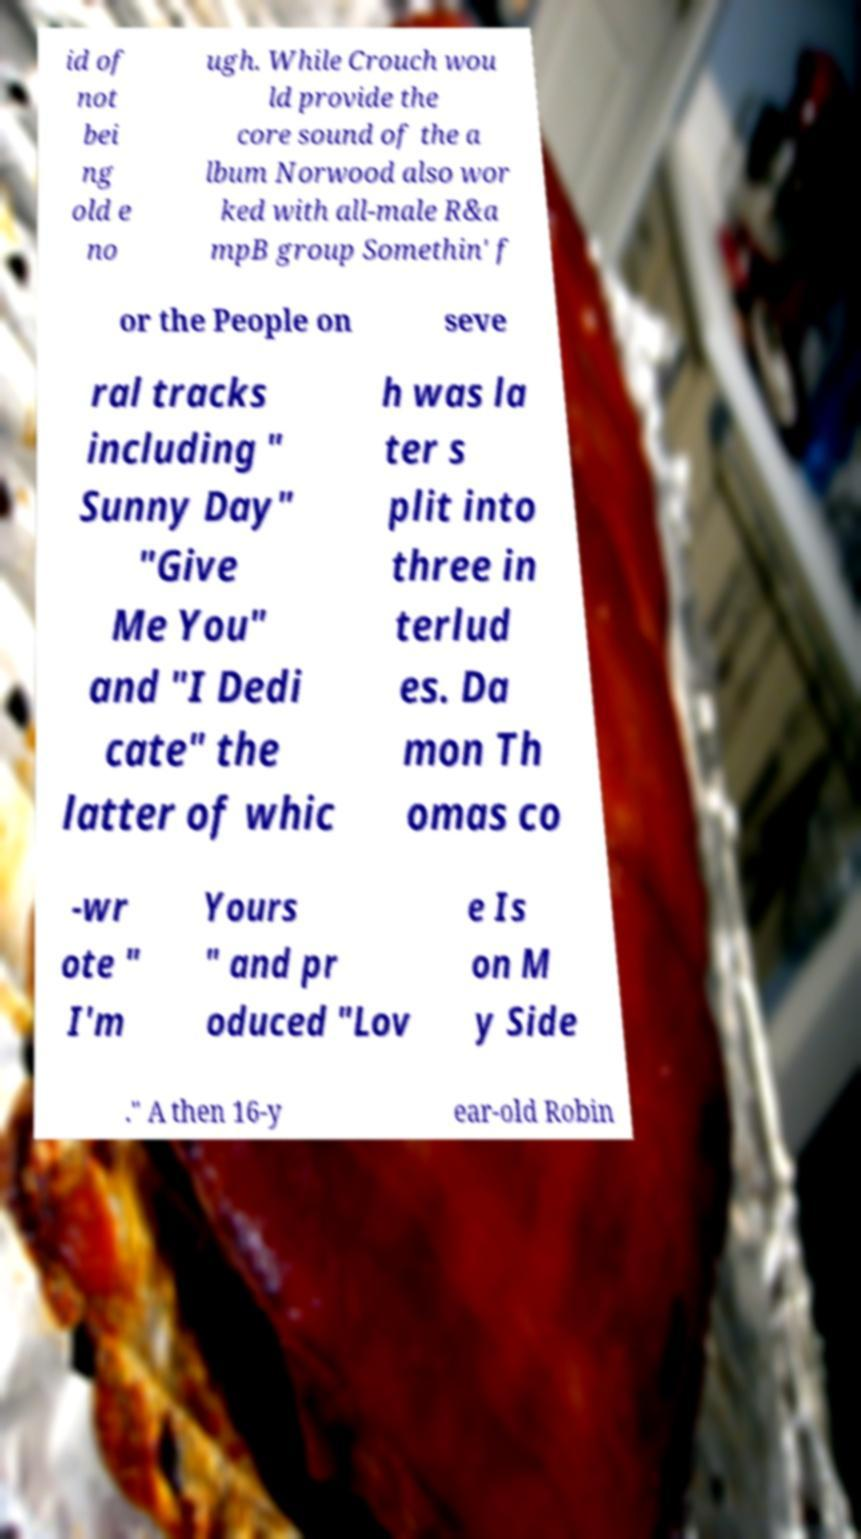There's text embedded in this image that I need extracted. Can you transcribe it verbatim? id of not bei ng old e no ugh. While Crouch wou ld provide the core sound of the a lbum Norwood also wor ked with all-male R&a mpB group Somethin' f or the People on seve ral tracks including " Sunny Day" "Give Me You" and "I Dedi cate" the latter of whic h was la ter s plit into three in terlud es. Da mon Th omas co -wr ote " I'm Yours " and pr oduced "Lov e Is on M y Side ." A then 16-y ear-old Robin 